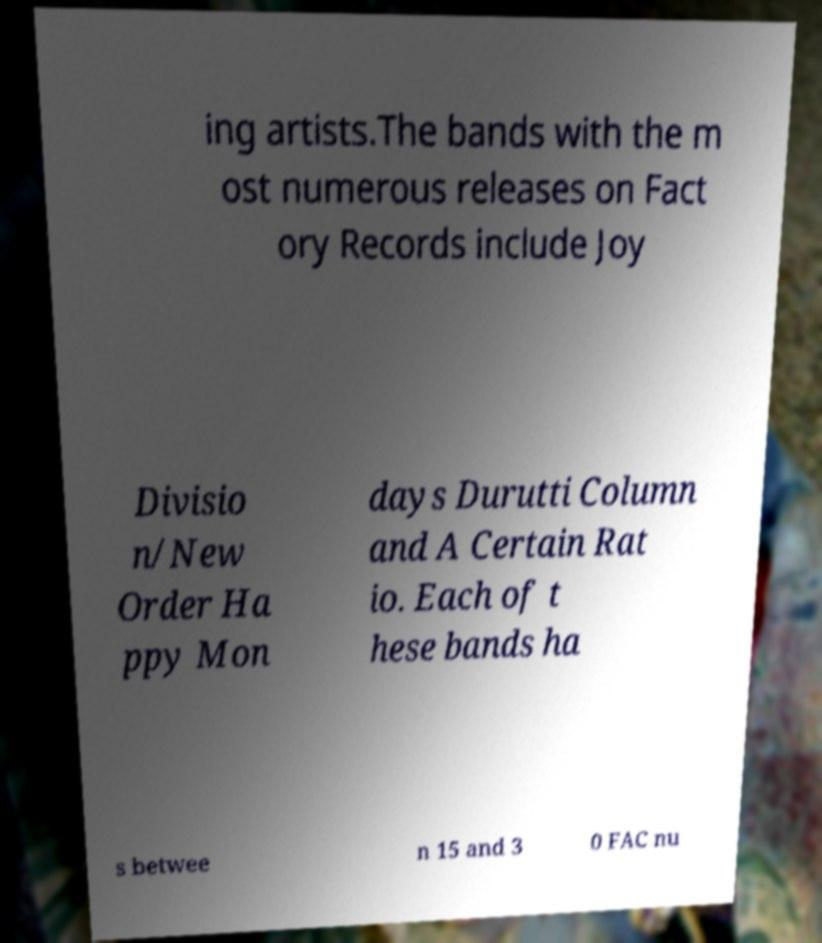For documentation purposes, I need the text within this image transcribed. Could you provide that? ing artists.The bands with the m ost numerous releases on Fact ory Records include Joy Divisio n/New Order Ha ppy Mon days Durutti Column and A Certain Rat io. Each of t hese bands ha s betwee n 15 and 3 0 FAC nu 